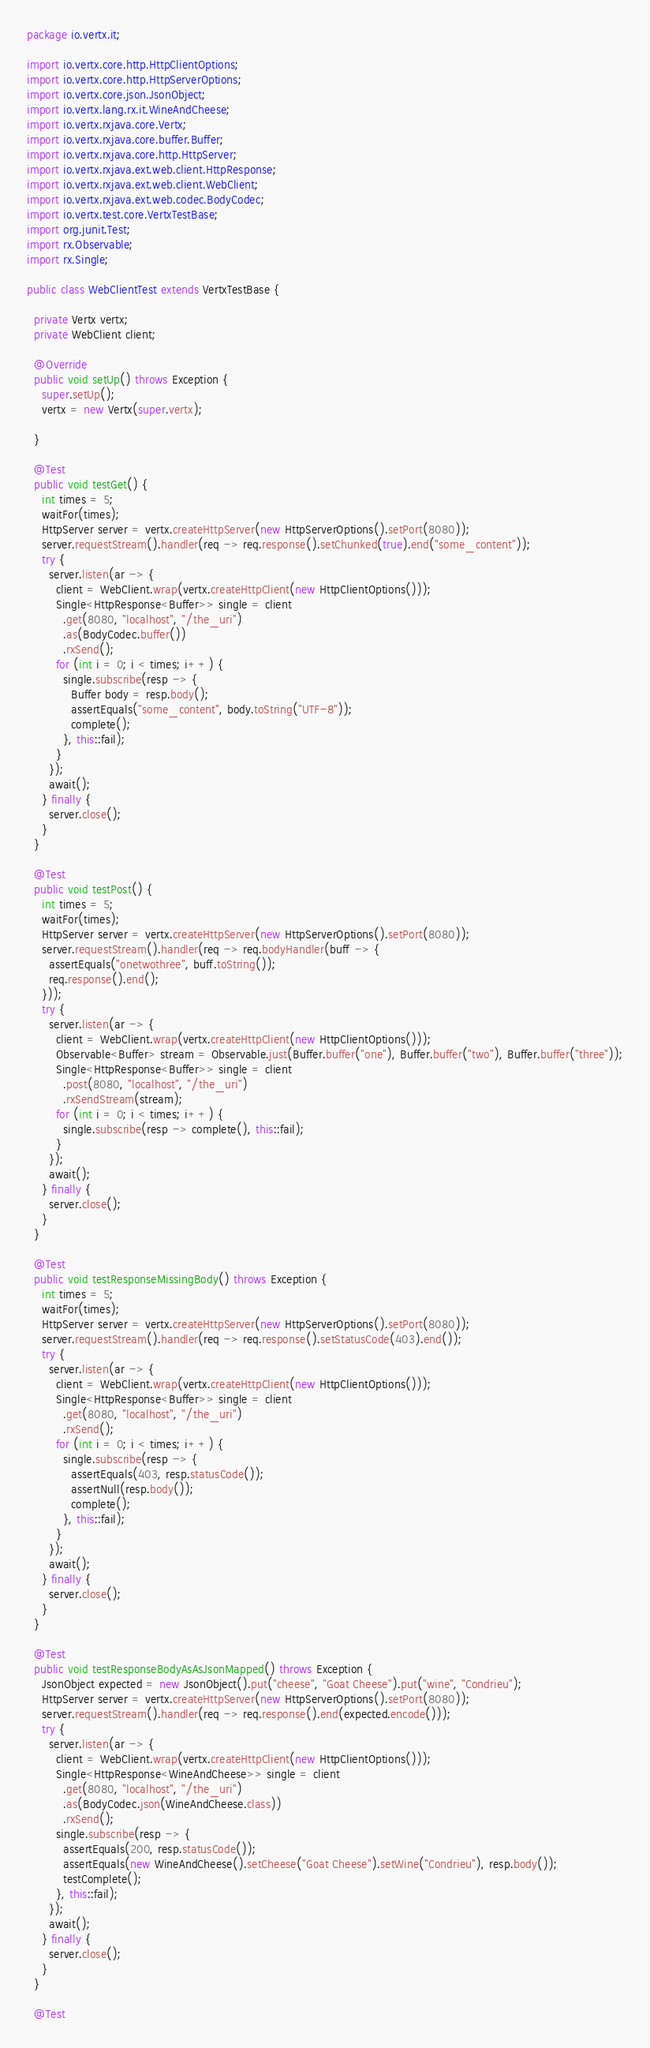<code> <loc_0><loc_0><loc_500><loc_500><_Java_>package io.vertx.it;

import io.vertx.core.http.HttpClientOptions;
import io.vertx.core.http.HttpServerOptions;
import io.vertx.core.json.JsonObject;
import io.vertx.lang.rx.it.WineAndCheese;
import io.vertx.rxjava.core.Vertx;
import io.vertx.rxjava.core.buffer.Buffer;
import io.vertx.rxjava.core.http.HttpServer;
import io.vertx.rxjava.ext.web.client.HttpResponse;
import io.vertx.rxjava.ext.web.client.WebClient;
import io.vertx.rxjava.ext.web.codec.BodyCodec;
import io.vertx.test.core.VertxTestBase;
import org.junit.Test;
import rx.Observable;
import rx.Single;

public class WebClientTest extends VertxTestBase {

  private Vertx vertx;
  private WebClient client;

  @Override
  public void setUp() throws Exception {
    super.setUp();
    vertx = new Vertx(super.vertx);

  }

  @Test
  public void testGet() {
    int times = 5;
    waitFor(times);
    HttpServer server = vertx.createHttpServer(new HttpServerOptions().setPort(8080));
    server.requestStream().handler(req -> req.response().setChunked(true).end("some_content"));
    try {
      server.listen(ar -> {
        client = WebClient.wrap(vertx.createHttpClient(new HttpClientOptions()));
        Single<HttpResponse<Buffer>> single = client
          .get(8080, "localhost", "/the_uri")
          .as(BodyCodec.buffer())
          .rxSend();
        for (int i = 0; i < times; i++) {
          single.subscribe(resp -> {
            Buffer body = resp.body();
            assertEquals("some_content", body.toString("UTF-8"));
            complete();
          }, this::fail);
        }
      });
      await();
    } finally {
      server.close();
    }
  }

  @Test
  public void testPost() {
    int times = 5;
    waitFor(times);
    HttpServer server = vertx.createHttpServer(new HttpServerOptions().setPort(8080));
    server.requestStream().handler(req -> req.bodyHandler(buff -> {
      assertEquals("onetwothree", buff.toString());
      req.response().end();
    }));
    try {
      server.listen(ar -> {
        client = WebClient.wrap(vertx.createHttpClient(new HttpClientOptions()));
        Observable<Buffer> stream = Observable.just(Buffer.buffer("one"), Buffer.buffer("two"), Buffer.buffer("three"));
        Single<HttpResponse<Buffer>> single = client
          .post(8080, "localhost", "/the_uri")
          .rxSendStream(stream);
        for (int i = 0; i < times; i++) {
          single.subscribe(resp -> complete(), this::fail);
        }
      });
      await();
    } finally {
      server.close();
    }
  }

  @Test
  public void testResponseMissingBody() throws Exception {
    int times = 5;
    waitFor(times);
    HttpServer server = vertx.createHttpServer(new HttpServerOptions().setPort(8080));
    server.requestStream().handler(req -> req.response().setStatusCode(403).end());
    try {
      server.listen(ar -> {
        client = WebClient.wrap(vertx.createHttpClient(new HttpClientOptions()));
        Single<HttpResponse<Buffer>> single = client
          .get(8080, "localhost", "/the_uri")
          .rxSend();
        for (int i = 0; i < times; i++) {
          single.subscribe(resp -> {
            assertEquals(403, resp.statusCode());
            assertNull(resp.body());
            complete();
          }, this::fail);
        }
      });
      await();
    } finally {
      server.close();
    }
  }

  @Test
  public void testResponseBodyAsAsJsonMapped() throws Exception {
    JsonObject expected = new JsonObject().put("cheese", "Goat Cheese").put("wine", "Condrieu");
    HttpServer server = vertx.createHttpServer(new HttpServerOptions().setPort(8080));
    server.requestStream().handler(req -> req.response().end(expected.encode()));
    try {
      server.listen(ar -> {
        client = WebClient.wrap(vertx.createHttpClient(new HttpClientOptions()));
        Single<HttpResponse<WineAndCheese>> single = client
          .get(8080, "localhost", "/the_uri")
          .as(BodyCodec.json(WineAndCheese.class))
          .rxSend();
        single.subscribe(resp -> {
          assertEquals(200, resp.statusCode());
          assertEquals(new WineAndCheese().setCheese("Goat Cheese").setWine("Condrieu"), resp.body());
          testComplete();
        }, this::fail);
      });
      await();
    } finally {
      server.close();
    }
  }

  @Test</code> 